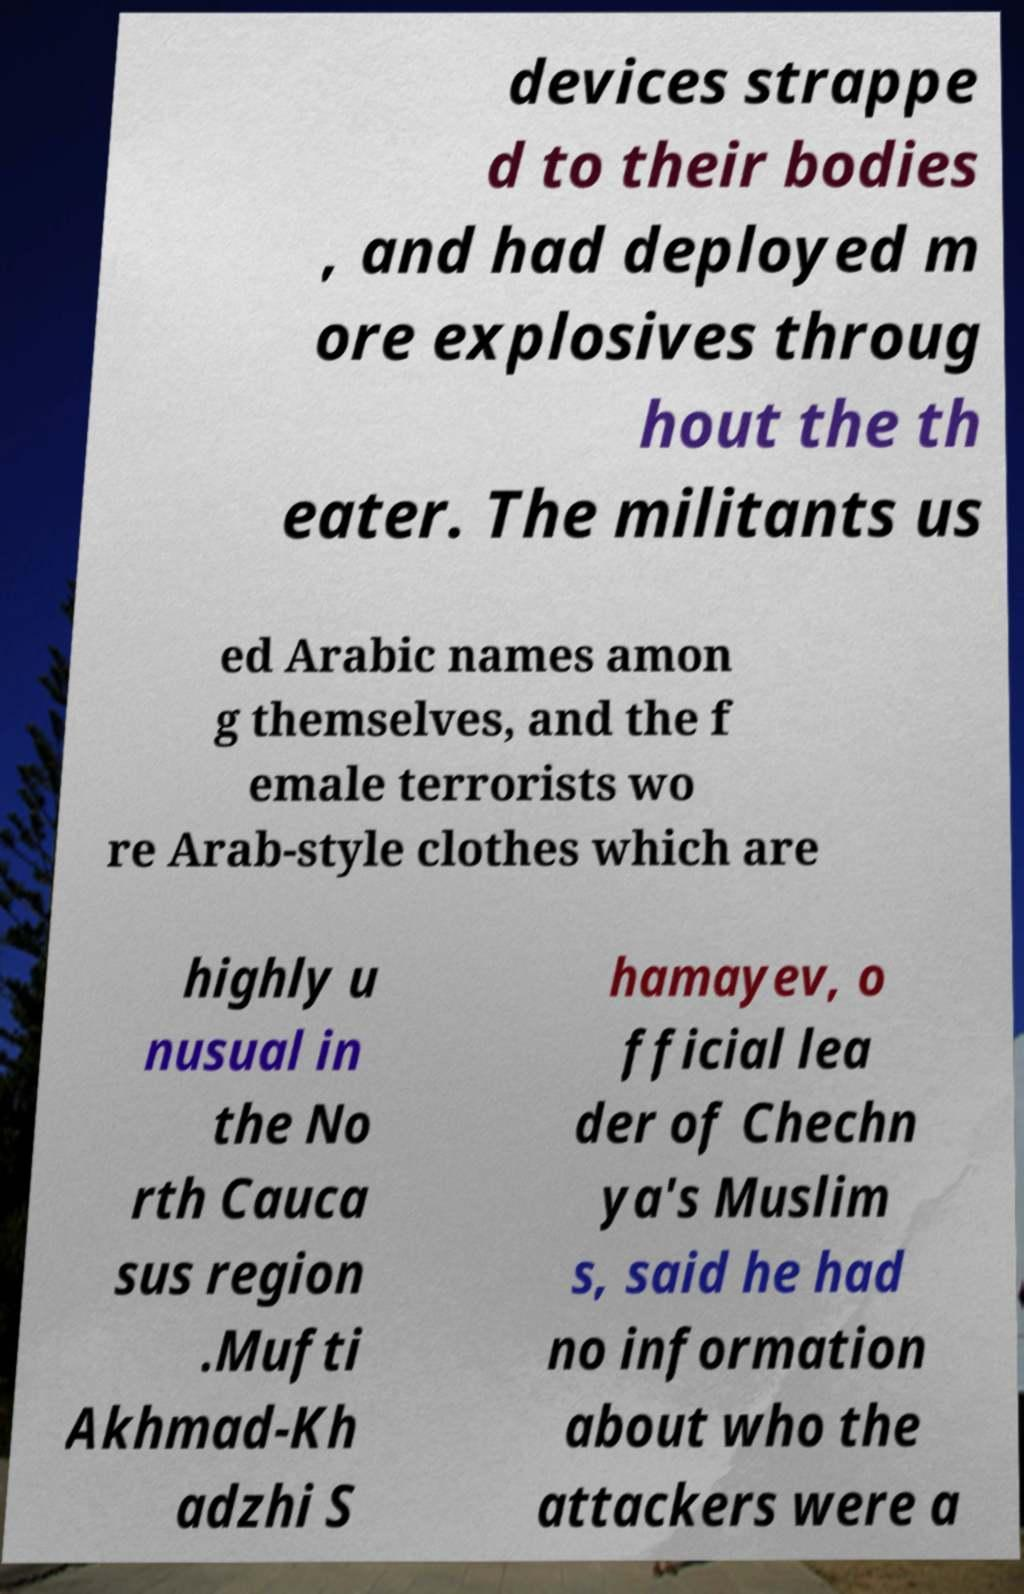Please read and relay the text visible in this image. What does it say? devices strappe d to their bodies , and had deployed m ore explosives throug hout the th eater. The militants us ed Arabic names amon g themselves, and the f emale terrorists wo re Arab-style clothes which are highly u nusual in the No rth Cauca sus region .Mufti Akhmad-Kh adzhi S hamayev, o fficial lea der of Chechn ya's Muslim s, said he had no information about who the attackers were a 